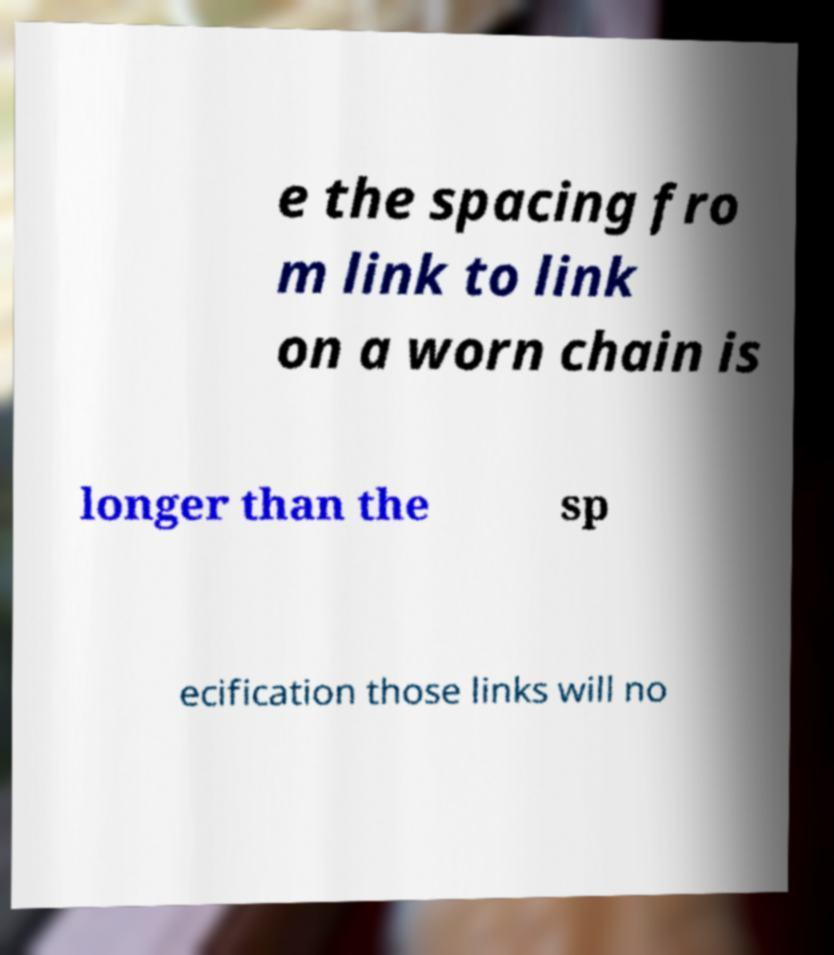Could you assist in decoding the text presented in this image and type it out clearly? e the spacing fro m link to link on a worn chain is longer than the sp ecification those links will no 